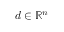Convert formula to latex. <formula><loc_0><loc_0><loc_500><loc_500>d \in \mathbb { R } ^ { n }</formula> 